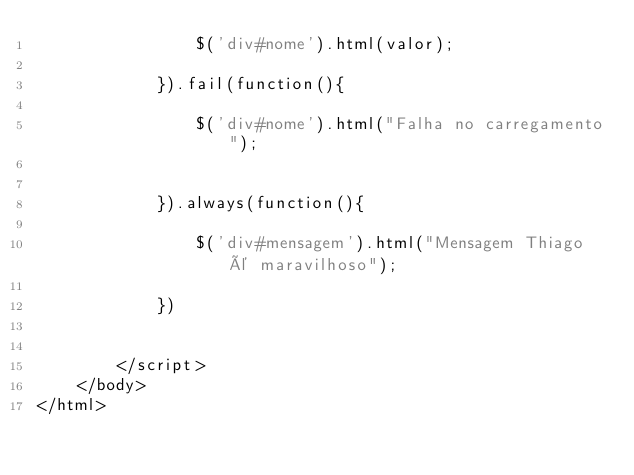Convert code to text. <code><loc_0><loc_0><loc_500><loc_500><_PHP_>                $('div#nome').html(valor);
                
            }).fail(function(){
                
                $('div#nome').html("Falha no carregamento");
                
                
            }).always(function(){
                
                $('div#mensagem').html("Mensagem Thiago é maravilhoso");
                                
            })
            
            
        </script>
    </body>
</html></code> 